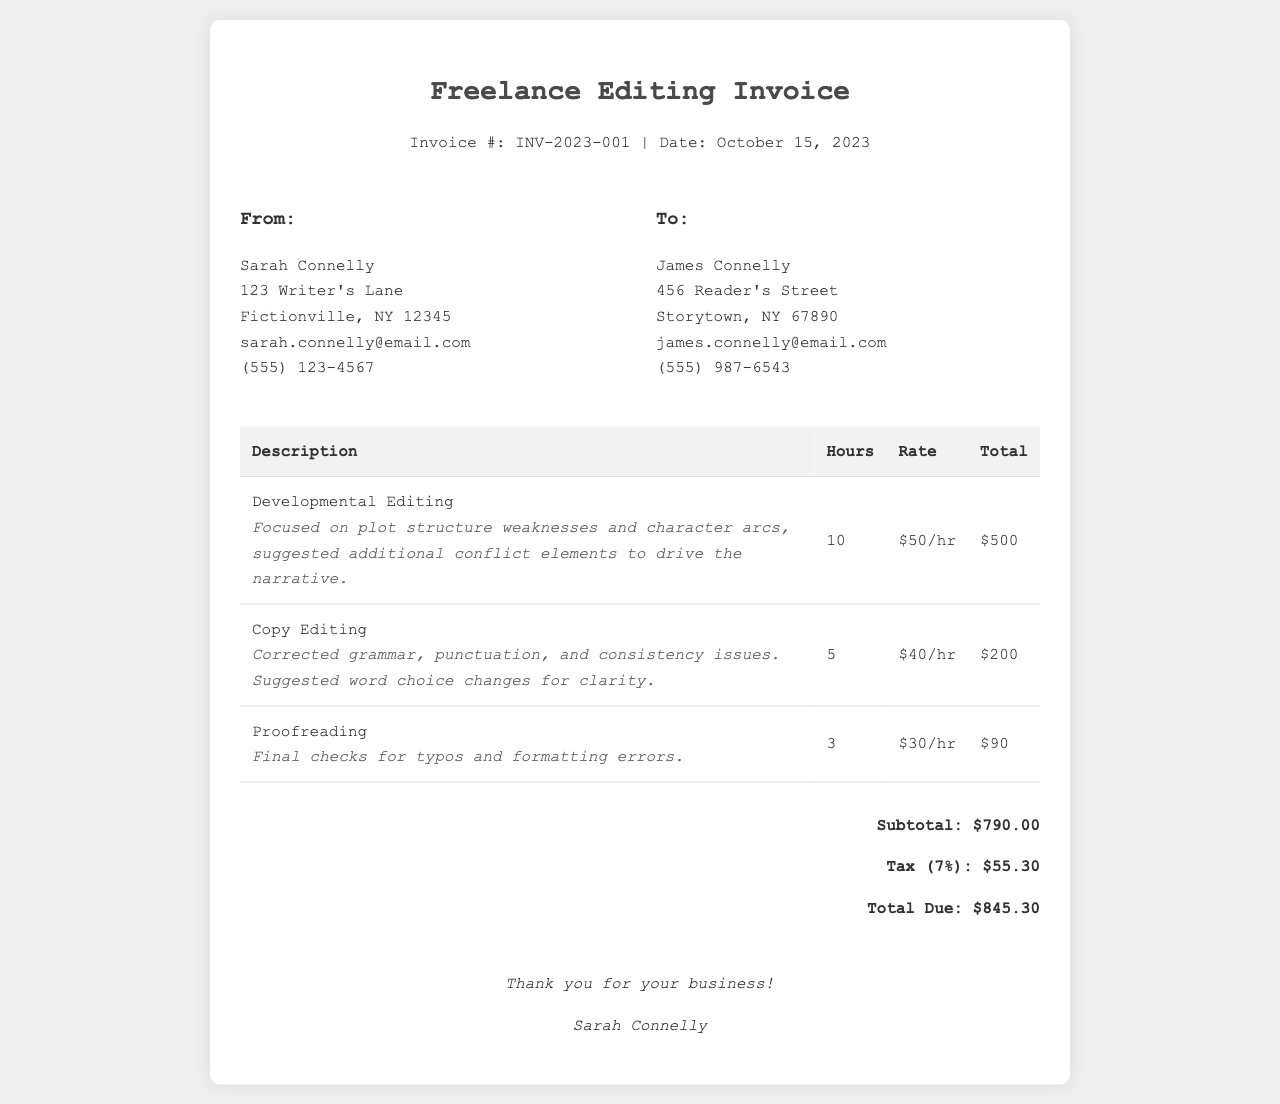What is the invoice number? The invoice number is presented at the top of the document as a unique identifier, which is INV-2023-001.
Answer: INV-2023-001 Who is the editor providing the services? The editor's name is at the beginning of the document, indicating who authored the invoice, which is Sarah Connelly.
Answer: Sarah Connelly How many hours were spent on developmental editing? The hours are listed under the description of each service, showing that 10 hours were spent on developmental editing.
Answer: 10 What is the total amount due including tax? The total amount due is calculated by adding the subtotal and tax, which is $845.30.
Answer: $845.30 What was one feedback point provided during developmental editing? The document includes feedback in a dedicated section, noting specific areas of improvement, such as weaknesses in plot structure and character arcs.
Answer: Plot structure weaknesses What is the hourly rate for copy editing? The rate for copy editing is specified next to the service description in the invoice table, which is $40/hr.
Answer: $40/hr What percentage tax is applied to the subtotal? The tax is stated in the document, indicating that a 7% tax is applied to the subtotal.
Answer: 7% How many hours were dedicated to proofreading? The hours for proofreading are explicitly listed in the invoice, where it shows that 3 hours were dedicated to this task.
Answer: 3 What is Sarah Connelly's email address? The editor's email address is provided under her contact information, which is sarah.connelly@email.com.
Answer: sarah.connelly@email.com 